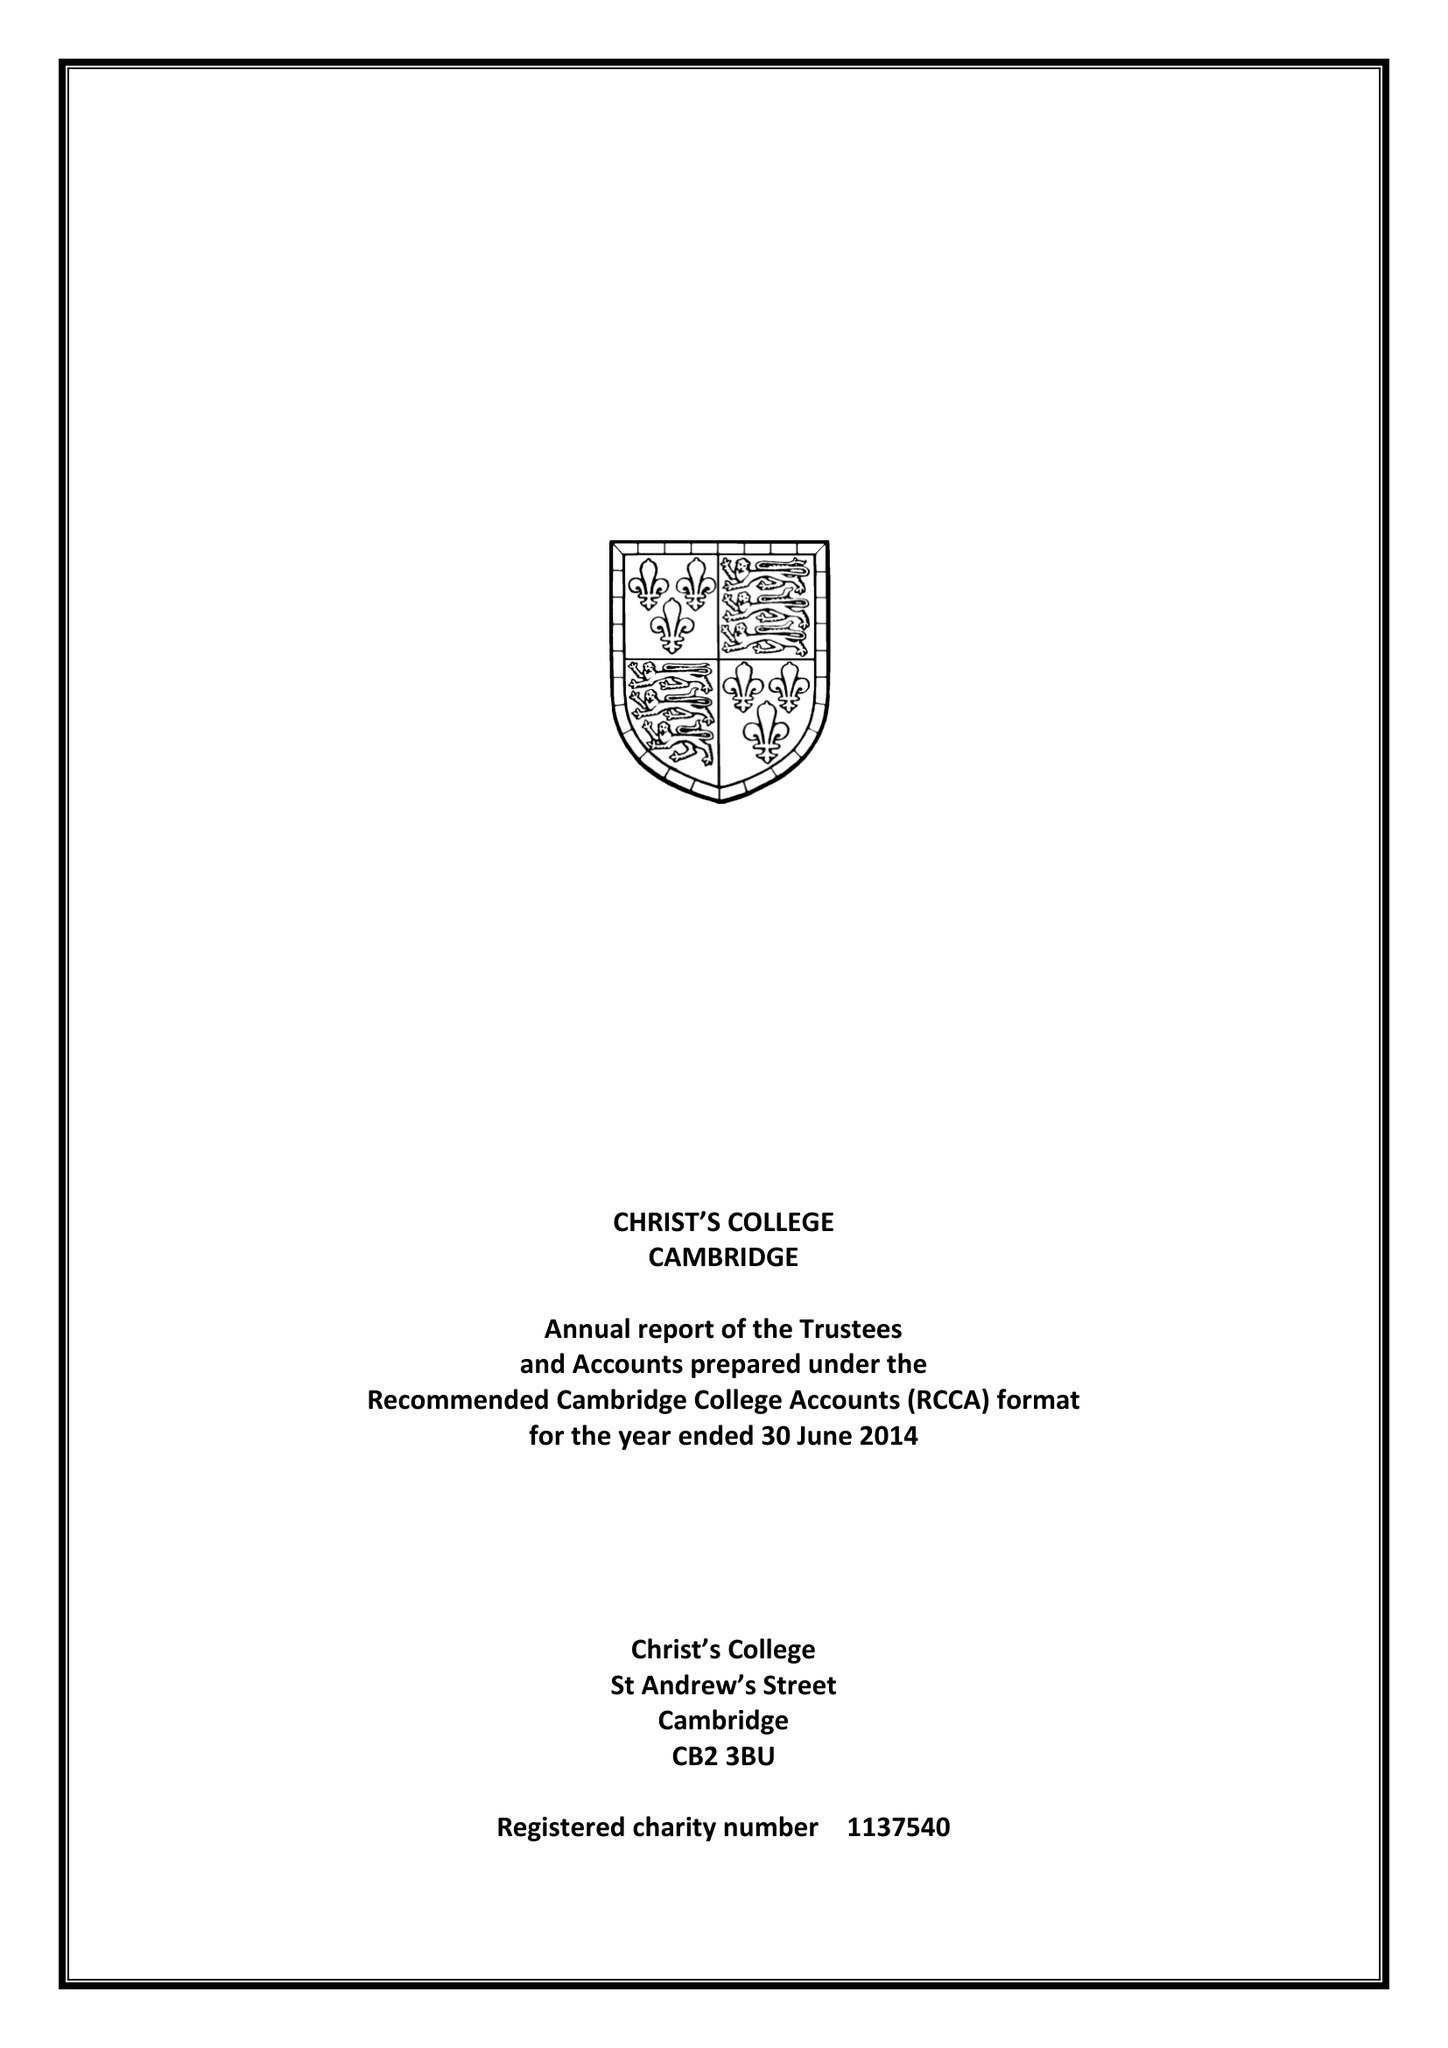What is the value for the address__post_town?
Answer the question using a single word or phrase. CAMBRIDGE 